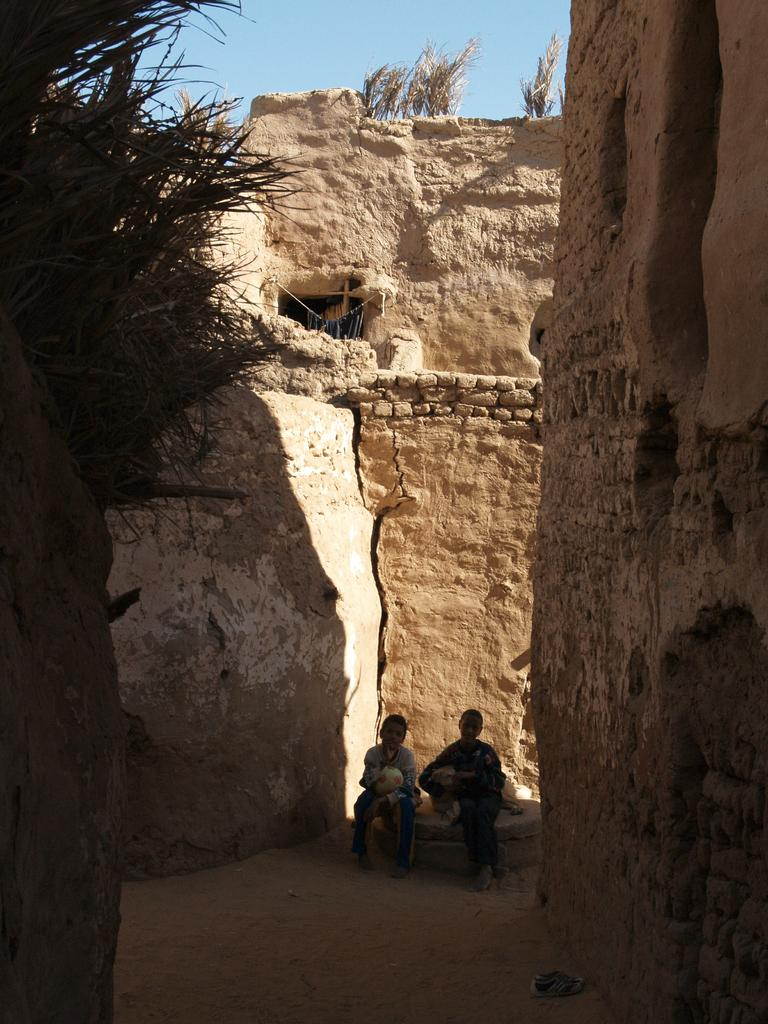How many people are in the image? There are two people in the image. What is the setting of the image? The people are sitting between brick walls. What are the people holding in the image? The people are holding objects. What type of vegetation is present in the image? There are plants in the image. What part of the natural environment is visible in the image? The sky is visible in the image. What type of brain can be seen in the image? There is no brain present in the image. How many dogs are visible in the image? There are no dogs present in the image. 